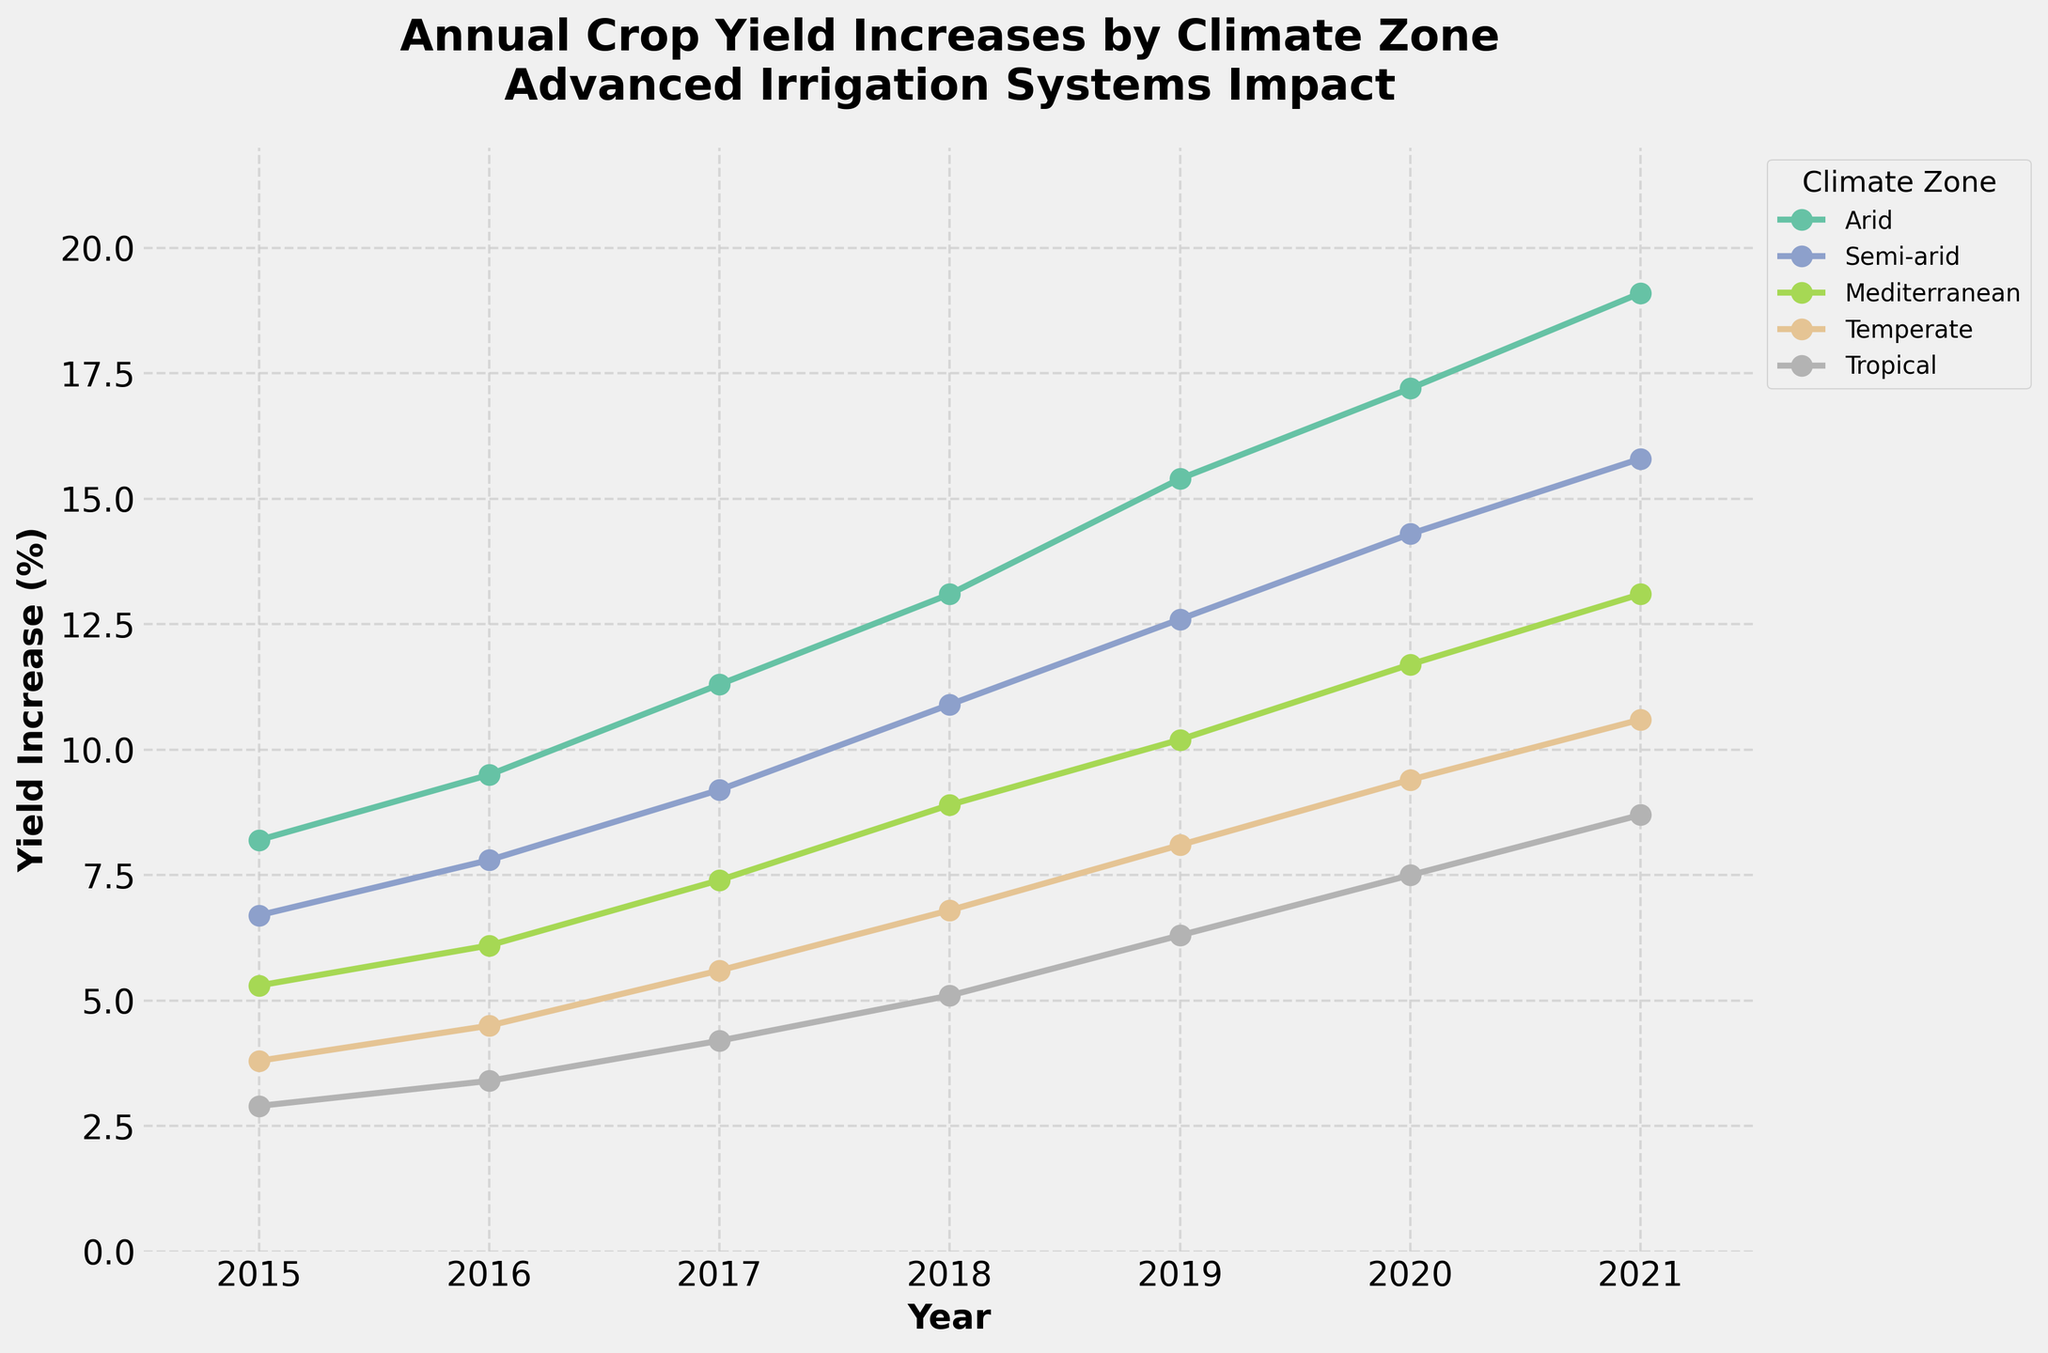What is the yield increase percentage for Arid zones in 2020? Locate the line representing the Arid climate zone, follow it to the year 2020, and read the value at that point.
Answer: 17.2% In which year did the Mediterranean zone experience the highest yield increase? Find the line representing the Mediterranean climate zone, trace it to the year with the highest value point.
Answer: 2021 Which climate zone had the lowest yield increase in 2015? Compare the values for all climate zones at the year 2015 and identify the smallest one.
Answer: Tropical How many percentage points did the yield increase in the Temperate zone between 2019 and 2021? Subtract the yield increase percentage at 2019 from that of 2021 for the Temperate zone.
Answer: 2.5 Which climate zone showed the most consistent increase in yield over the years? Visually assess the smoothness and linearity of the lines representing the yield increases for each climate zone over the years.
Answer: Temperate Does the yield increase in the Semi-arid zone ever surpass that of the Arid zone? Compare the lines of the Semi-arid and Arid climate zones over the years; observe if the Semi-arid line ever goes higher than the Arid line.
Answer: No What is the average yield increase percentage across all zones in 2017? Calculate the sum of yield increases for all zones in 2017 and divide by the number of zones. [(11.3 + 9.2 + 7.4 + 5.6 + 4.2) / 5]
Answer: 7.54 By how many percentage points did the Mediterranean zone's yield increase improve from 2018 to 2021? Subtract the yield increase percentage of 2018 from that of 2021 in the Mediterranean zone.
Answer: 4.2 Which zone had the steepest increase in yield percentage between 2015 and 2021? Determine which line has the highest slope from 2015 to 2021.
Answer: Arid In 2019, which two climate zones had the smallest difference in yield increase percentages? Compare the yield increases for each pair of climate zones in 2019 and find the pair with the smallest difference.
Answer: Mediterranean and Temperate 